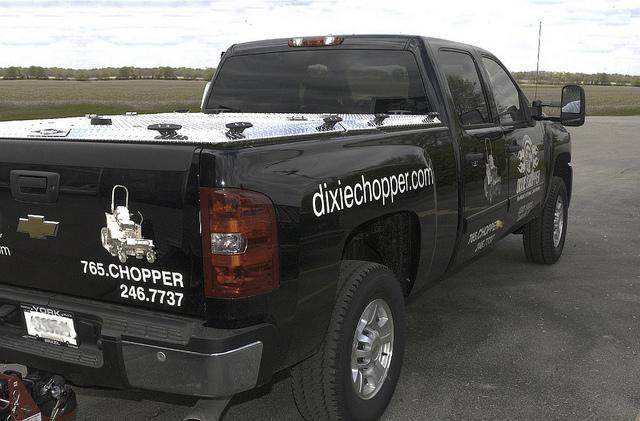How many tires do you see?
Give a very brief answer. 2. How many trucks are there?
Give a very brief answer. 1. How many dogs are playing here?
Give a very brief answer. 0. 